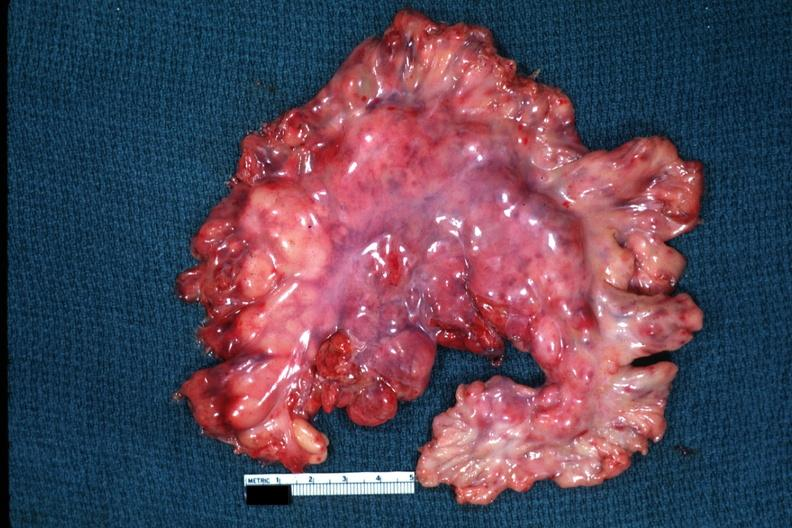what is present?
Answer the question using a single word or phrase. Abdomen 